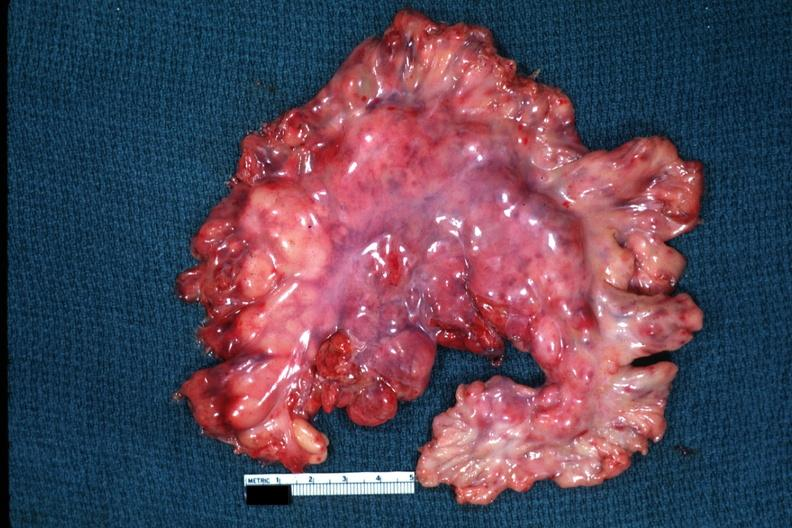what is present?
Answer the question using a single word or phrase. Abdomen 